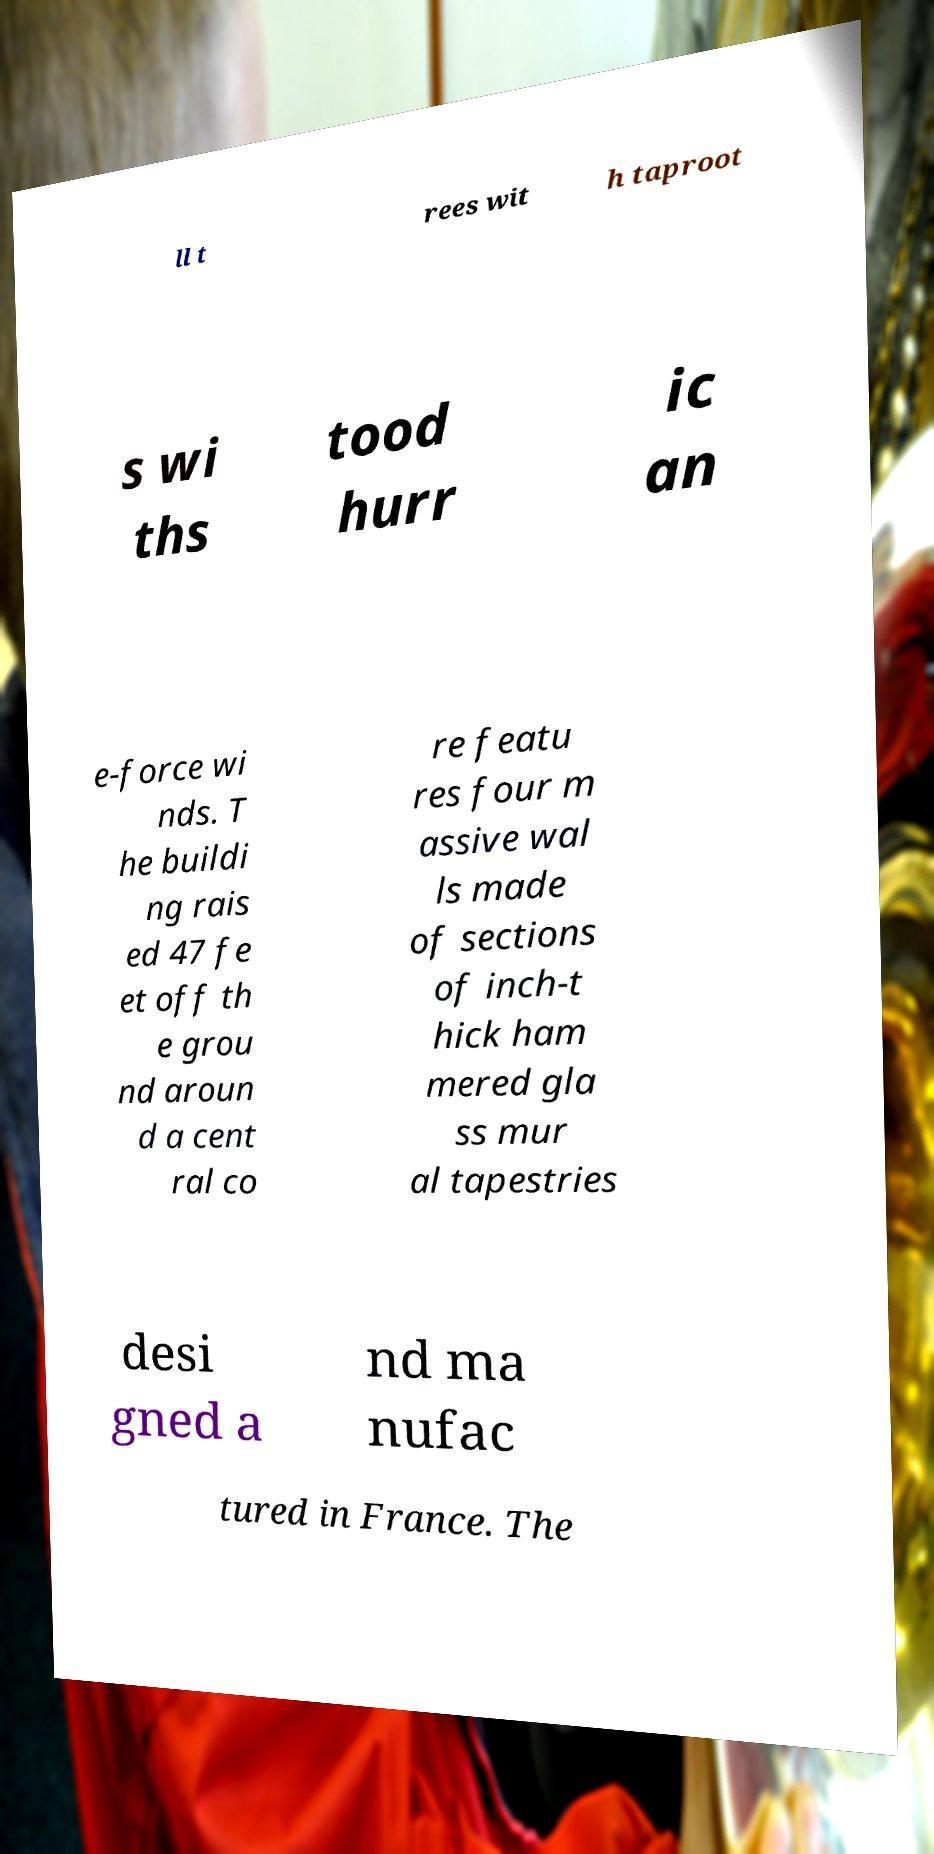Please identify and transcribe the text found in this image. ll t rees wit h taproot s wi ths tood hurr ic an e-force wi nds. T he buildi ng rais ed 47 fe et off th e grou nd aroun d a cent ral co re featu res four m assive wal ls made of sections of inch-t hick ham mered gla ss mur al tapestries desi gned a nd ma nufac tured in France. The 